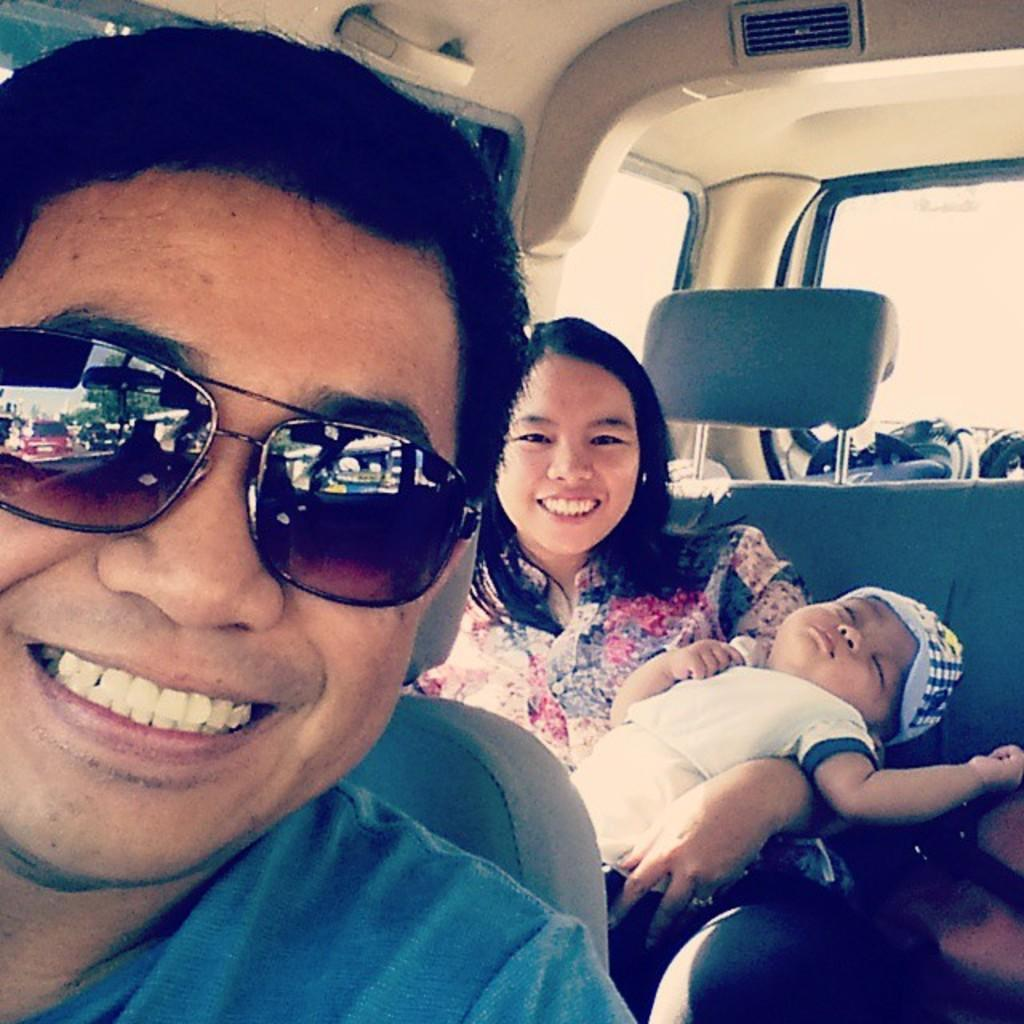What type of setting is depicted in the image? The image shows an inside view of a vehicle. Who is present in the vehicle? There is a man and a woman sitting in the vehicle. What is the woman holding? The woman is holding a baby. What is the man in the front wearing? The man in the front is wearing goggles. What type of stocking is hanging from the ceiling in the image? There is no stocking hanging from the ceiling in the image; it depicts an inside view of a vehicle with a man, a woman, and a baby. Can you tell me how many quartz crystals are on the dashboard? There are no quartz crystals present in the image; it shows an inside view of a vehicle with a man, a woman, and a baby. 